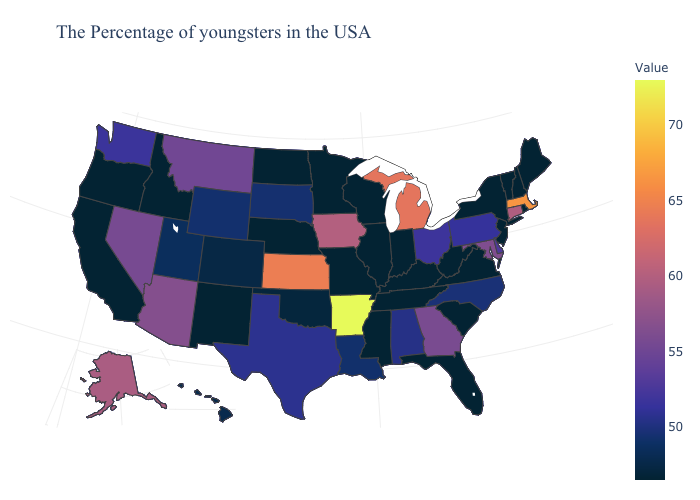Does Kentucky have the lowest value in the South?
Keep it brief. Yes. Does the map have missing data?
Answer briefly. No. Does Washington have a higher value than Alaska?
Quick response, please. No. Does the map have missing data?
Keep it brief. No. Which states have the highest value in the USA?
Quick response, please. Arkansas. 